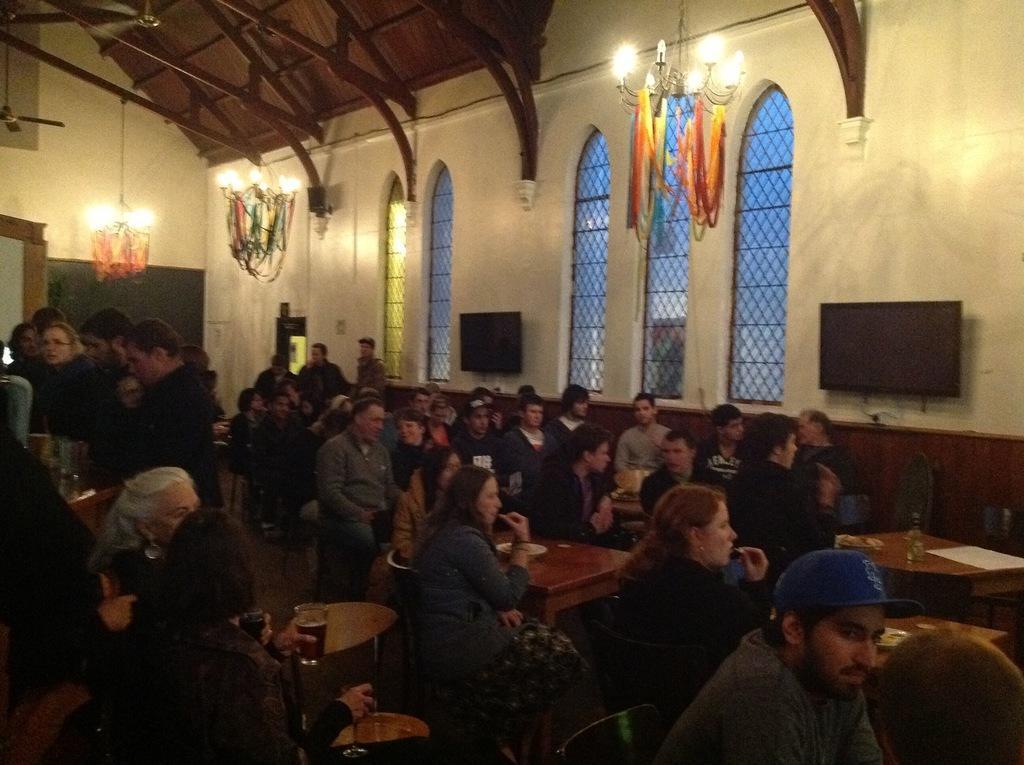Can you describe this image briefly? In this image, there are a few people. We can see some tables with objects. We can see some televisions. We can see some chairs. We can see the wall with some glass windows. We can also see some lights and banners. We can see the ground. We can also see the roof and some fans. 